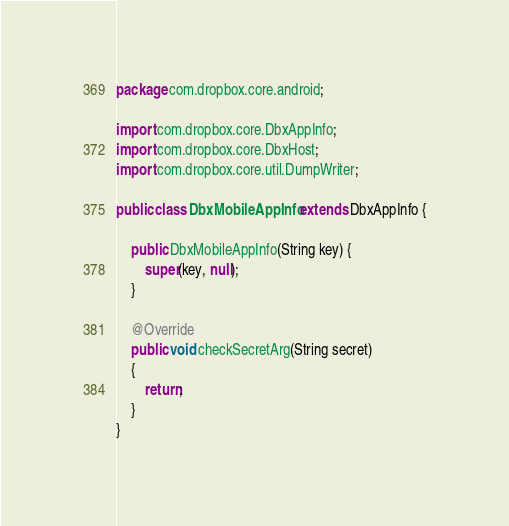<code> <loc_0><loc_0><loc_500><loc_500><_Java_>package com.dropbox.core.android;

import com.dropbox.core.DbxAppInfo;
import com.dropbox.core.DbxHost;
import com.dropbox.core.util.DumpWriter;

public class DbxMobileAppInfo extends DbxAppInfo {

    public DbxMobileAppInfo(String key) {
        super(key, null);
    }

    @Override
    public void checkSecretArg(String secret)
    {
        return;
    }
}
</code> 